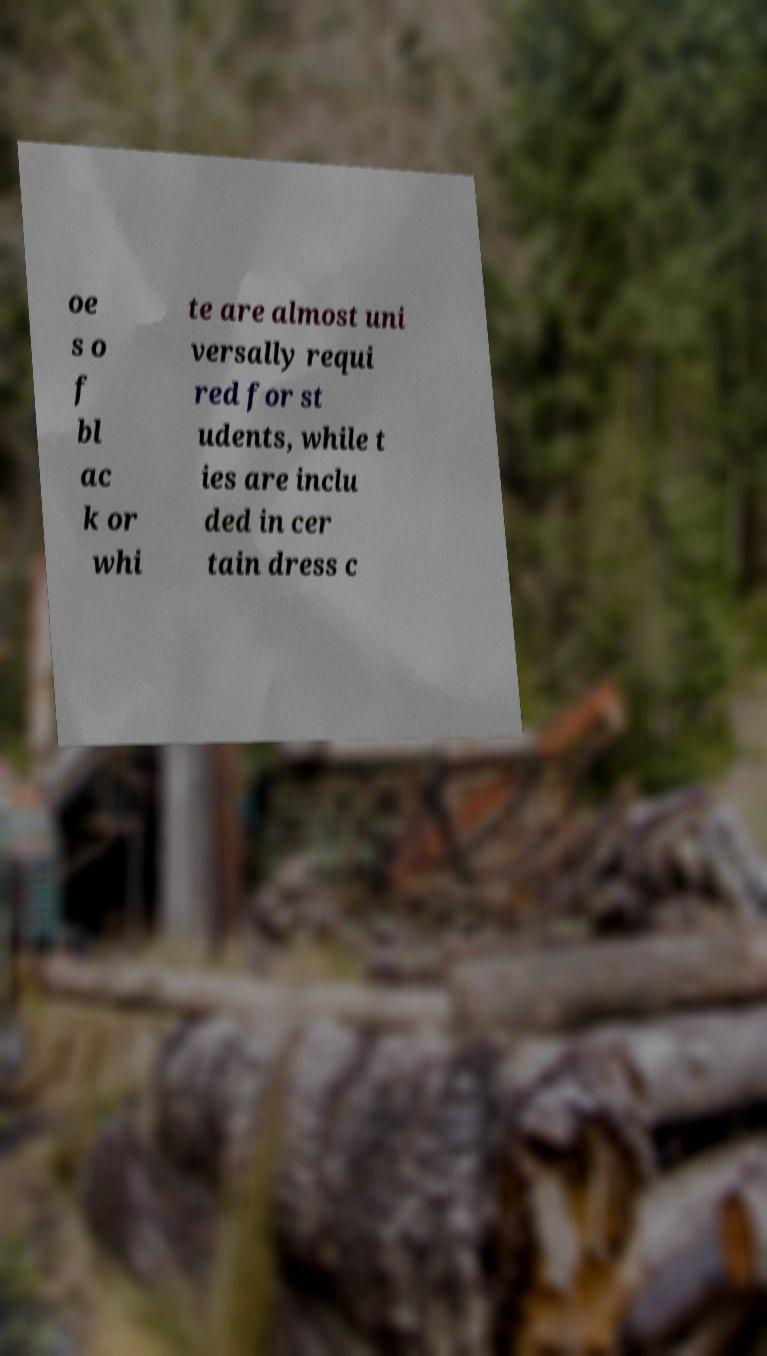What messages or text are displayed in this image? I need them in a readable, typed format. oe s o f bl ac k or whi te are almost uni versally requi red for st udents, while t ies are inclu ded in cer tain dress c 